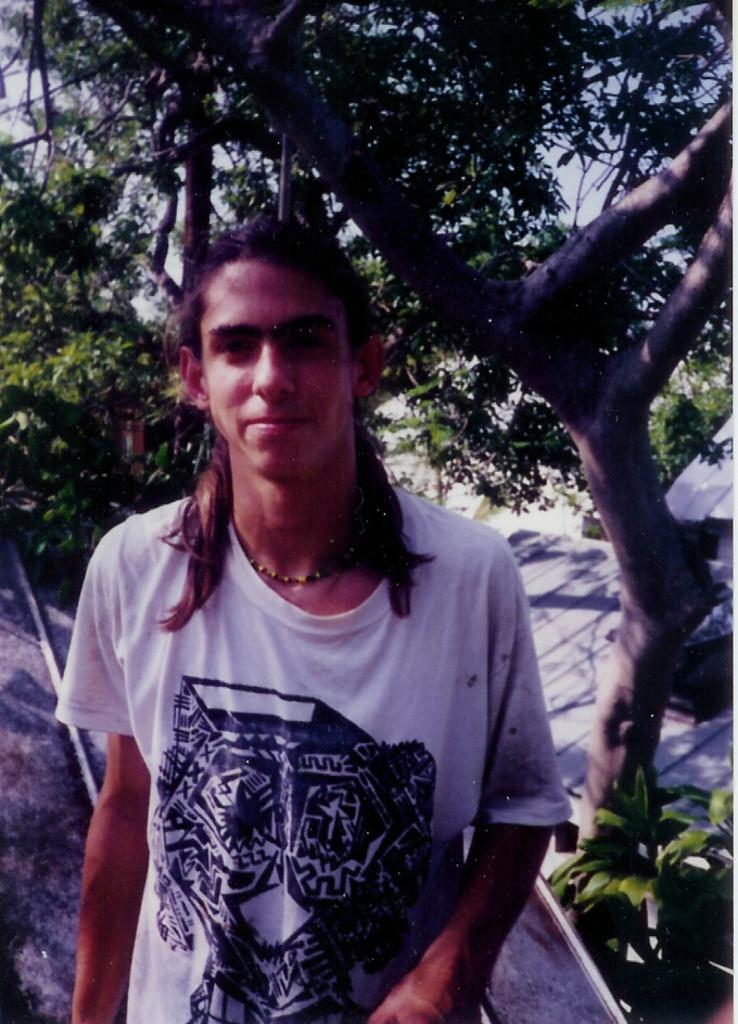What is the main subject in the middle of the image? There is a person in the middle of the image. What can be seen in the background of the image? There are trees and plants in the background of the image. What type of quartz can be seen on the person's wrist in the image? There is no quartz visible on the person's wrist in the image. How many steps does the person take during their voyage in the image? There is no indication of a voyage or steps taken by the person in the image. 